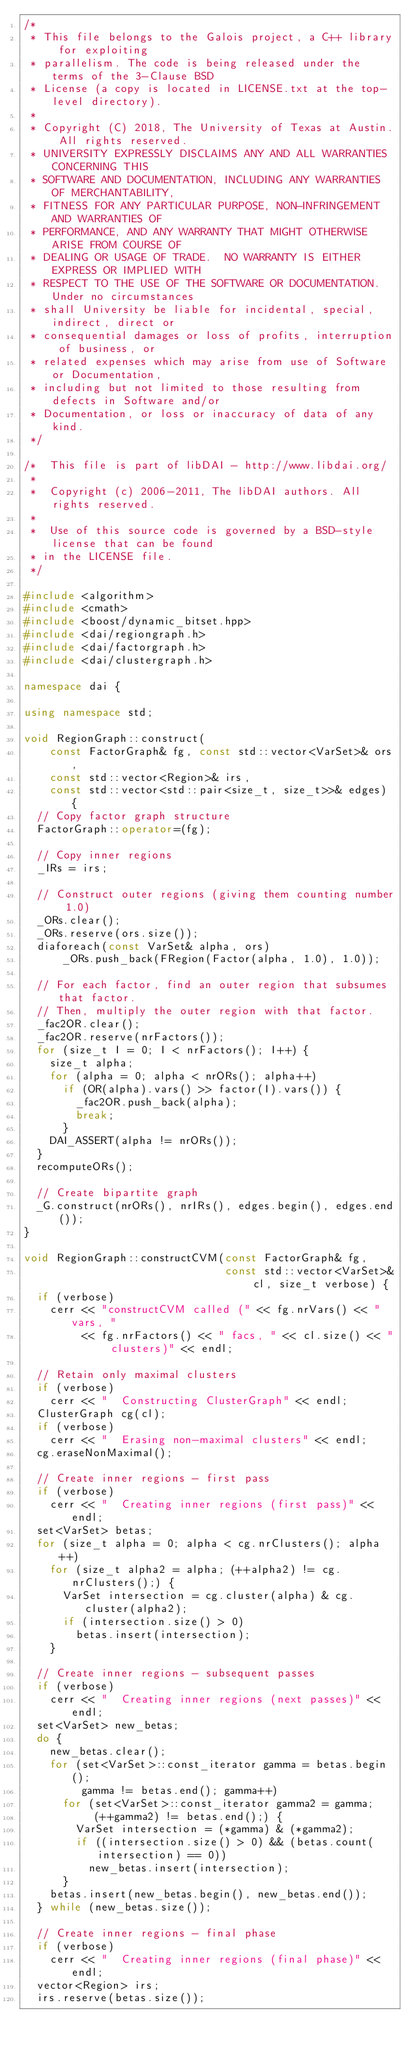<code> <loc_0><loc_0><loc_500><loc_500><_C++_>/*
 * This file belongs to the Galois project, a C++ library for exploiting
 * parallelism. The code is being released under the terms of the 3-Clause BSD
 * License (a copy is located in LICENSE.txt at the top-level directory).
 *
 * Copyright (C) 2018, The University of Texas at Austin. All rights reserved.
 * UNIVERSITY EXPRESSLY DISCLAIMS ANY AND ALL WARRANTIES CONCERNING THIS
 * SOFTWARE AND DOCUMENTATION, INCLUDING ANY WARRANTIES OF MERCHANTABILITY,
 * FITNESS FOR ANY PARTICULAR PURPOSE, NON-INFRINGEMENT AND WARRANTIES OF
 * PERFORMANCE, AND ANY WARRANTY THAT MIGHT OTHERWISE ARISE FROM COURSE OF
 * DEALING OR USAGE OF TRADE.  NO WARRANTY IS EITHER EXPRESS OR IMPLIED WITH
 * RESPECT TO THE USE OF THE SOFTWARE OR DOCUMENTATION. Under no circumstances
 * shall University be liable for incidental, special, indirect, direct or
 * consequential damages or loss of profits, interruption of business, or
 * related expenses which may arise from use of Software or Documentation,
 * including but not limited to those resulting from defects in Software and/or
 * Documentation, or loss or inaccuracy of data of any kind.
 */

/*  This file is part of libDAI - http://www.libdai.org/
 *
 *  Copyright (c) 2006-2011, The libDAI authors. All rights reserved.
 *
 *  Use of this source code is governed by a BSD-style license that can be found
 * in the LICENSE file.
 */

#include <algorithm>
#include <cmath>
#include <boost/dynamic_bitset.hpp>
#include <dai/regiongraph.h>
#include <dai/factorgraph.h>
#include <dai/clustergraph.h>

namespace dai {

using namespace std;

void RegionGraph::construct(
    const FactorGraph& fg, const std::vector<VarSet>& ors,
    const std::vector<Region>& irs,
    const std::vector<std::pair<size_t, size_t>>& edges) {
  // Copy factor graph structure
  FactorGraph::operator=(fg);

  // Copy inner regions
  _IRs = irs;

  // Construct outer regions (giving them counting number 1.0)
  _ORs.clear();
  _ORs.reserve(ors.size());
  diaforeach(const VarSet& alpha, ors)
      _ORs.push_back(FRegion(Factor(alpha, 1.0), 1.0));

  // For each factor, find an outer region that subsumes that factor.
  // Then, multiply the outer region with that factor.
  _fac2OR.clear();
  _fac2OR.reserve(nrFactors());
  for (size_t I = 0; I < nrFactors(); I++) {
    size_t alpha;
    for (alpha = 0; alpha < nrORs(); alpha++)
      if (OR(alpha).vars() >> factor(I).vars()) {
        _fac2OR.push_back(alpha);
        break;
      }
    DAI_ASSERT(alpha != nrORs());
  }
  recomputeORs();

  // Create bipartite graph
  _G.construct(nrORs(), nrIRs(), edges.begin(), edges.end());
}

void RegionGraph::constructCVM(const FactorGraph& fg,
                               const std::vector<VarSet>& cl, size_t verbose) {
  if (verbose)
    cerr << "constructCVM called (" << fg.nrVars() << " vars, "
         << fg.nrFactors() << " facs, " << cl.size() << " clusters)" << endl;

  // Retain only maximal clusters
  if (verbose)
    cerr << "  Constructing ClusterGraph" << endl;
  ClusterGraph cg(cl);
  if (verbose)
    cerr << "  Erasing non-maximal clusters" << endl;
  cg.eraseNonMaximal();

  // Create inner regions - first pass
  if (verbose)
    cerr << "  Creating inner regions (first pass)" << endl;
  set<VarSet> betas;
  for (size_t alpha = 0; alpha < cg.nrClusters(); alpha++)
    for (size_t alpha2 = alpha; (++alpha2) != cg.nrClusters();) {
      VarSet intersection = cg.cluster(alpha) & cg.cluster(alpha2);
      if (intersection.size() > 0)
        betas.insert(intersection);
    }

  // Create inner regions - subsequent passes
  if (verbose)
    cerr << "  Creating inner regions (next passes)" << endl;
  set<VarSet> new_betas;
  do {
    new_betas.clear();
    for (set<VarSet>::const_iterator gamma = betas.begin();
         gamma != betas.end(); gamma++)
      for (set<VarSet>::const_iterator gamma2 = gamma;
           (++gamma2) != betas.end();) {
        VarSet intersection = (*gamma) & (*gamma2);
        if ((intersection.size() > 0) && (betas.count(intersection) == 0))
          new_betas.insert(intersection);
      }
    betas.insert(new_betas.begin(), new_betas.end());
  } while (new_betas.size());

  // Create inner regions - final phase
  if (verbose)
    cerr << "  Creating inner regions (final phase)" << endl;
  vector<Region> irs;
  irs.reserve(betas.size());</code> 